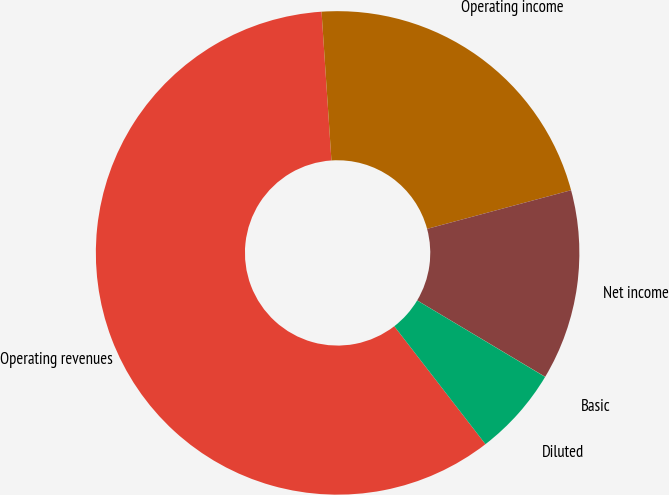Convert chart to OTSL. <chart><loc_0><loc_0><loc_500><loc_500><pie_chart><fcel>Operating revenues<fcel>Operating income<fcel>Net income<fcel>Basic<fcel>Diluted<nl><fcel>59.41%<fcel>21.88%<fcel>12.74%<fcel>0.01%<fcel>5.95%<nl></chart> 